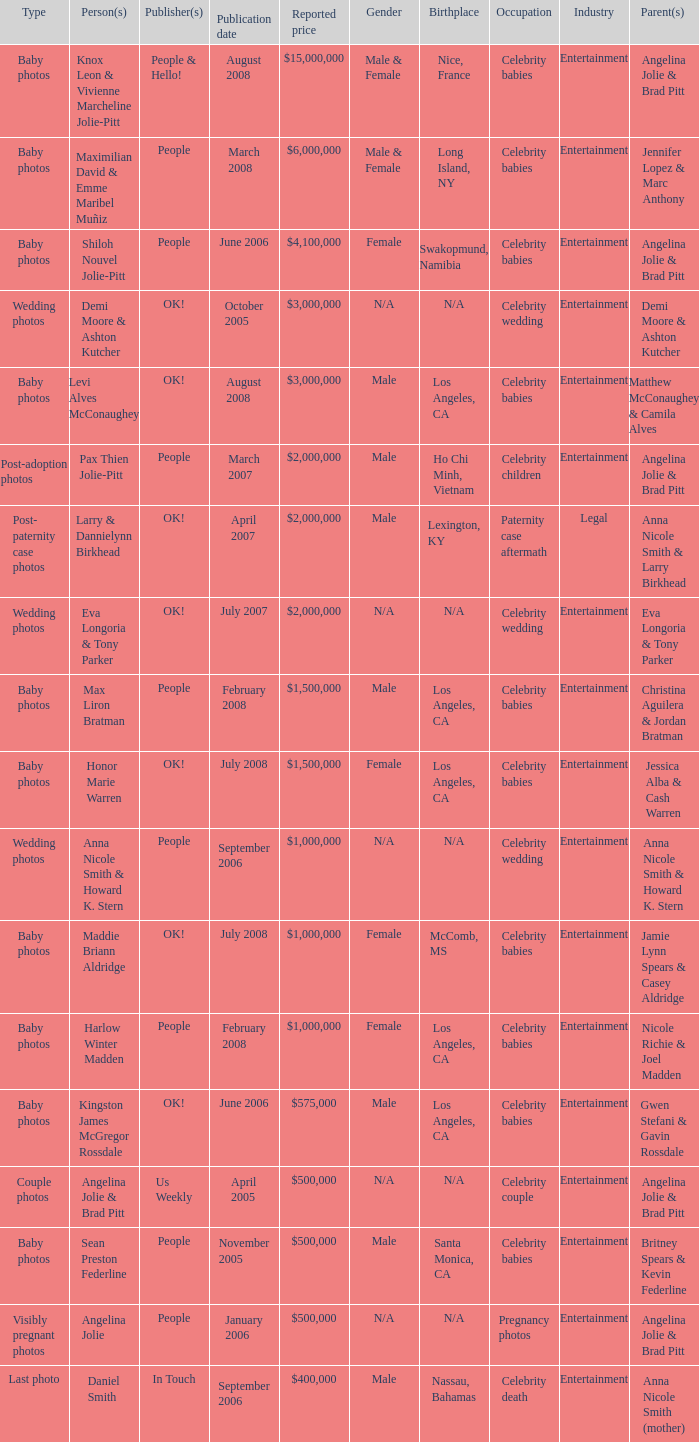What was the publication date of the photos of Sean Preston Federline that cost $500,000 and were published by People? November 2005. 